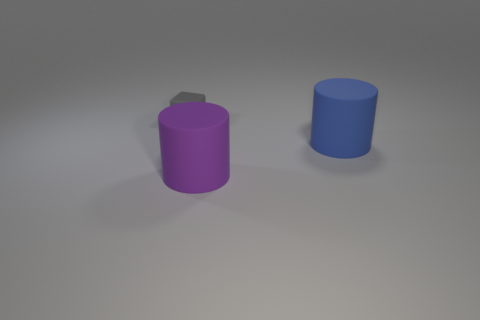Add 1 big gray shiny cylinders. How many objects exist? 4 Subtract all blocks. How many objects are left? 2 Add 3 big matte cylinders. How many big matte cylinders are left? 5 Add 1 blue objects. How many blue objects exist? 2 Subtract 1 gray blocks. How many objects are left? 2 Subtract all tiny gray rubber objects. Subtract all gray blocks. How many objects are left? 1 